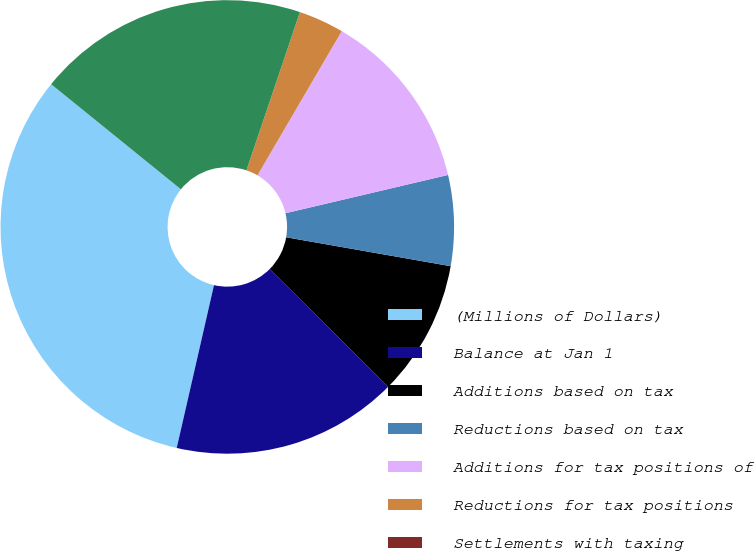<chart> <loc_0><loc_0><loc_500><loc_500><pie_chart><fcel>(Millions of Dollars)<fcel>Balance at Jan 1<fcel>Additions based on tax<fcel>Reductions based on tax<fcel>Additions for tax positions of<fcel>Reductions for tax positions<fcel>Settlements with taxing<fcel>Balance at Dec 31<nl><fcel>32.25%<fcel>16.13%<fcel>9.68%<fcel>6.45%<fcel>12.9%<fcel>3.23%<fcel>0.0%<fcel>19.35%<nl></chart> 